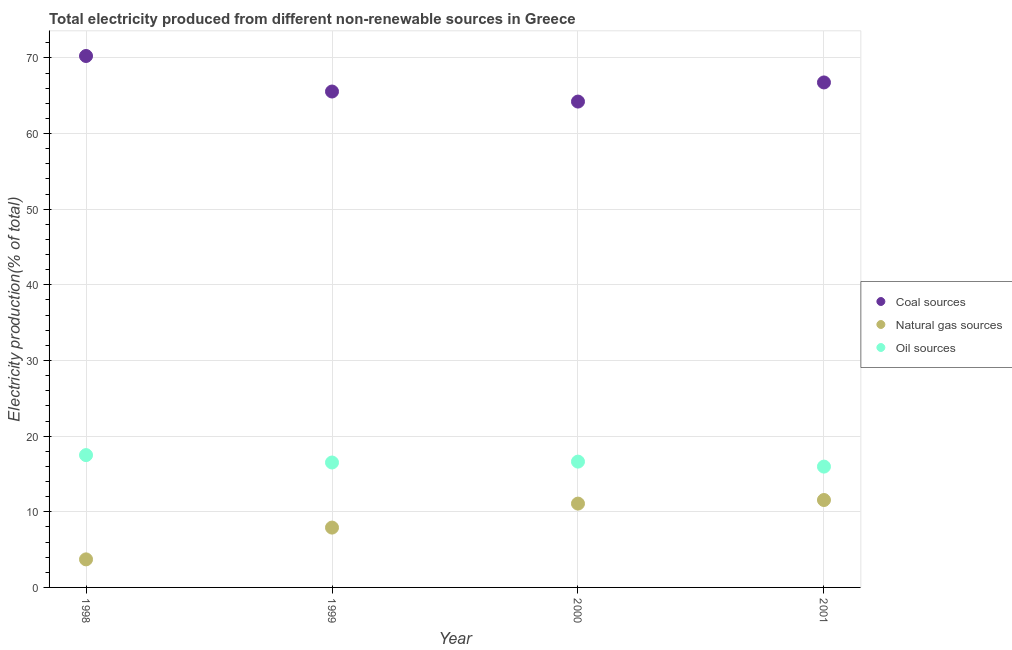How many different coloured dotlines are there?
Your answer should be very brief. 3. Is the number of dotlines equal to the number of legend labels?
Offer a terse response. Yes. What is the percentage of electricity produced by oil sources in 2001?
Your answer should be compact. 15.97. Across all years, what is the maximum percentage of electricity produced by coal?
Your answer should be compact. 70.25. Across all years, what is the minimum percentage of electricity produced by natural gas?
Provide a succinct answer. 3.71. In which year was the percentage of electricity produced by oil sources maximum?
Make the answer very short. 1998. In which year was the percentage of electricity produced by natural gas minimum?
Your response must be concise. 1998. What is the total percentage of electricity produced by natural gas in the graph?
Provide a succinct answer. 34.26. What is the difference between the percentage of electricity produced by oil sources in 1998 and that in 2000?
Provide a succinct answer. 0.86. What is the difference between the percentage of electricity produced by coal in 1999 and the percentage of electricity produced by oil sources in 2000?
Your answer should be very brief. 48.92. What is the average percentage of electricity produced by oil sources per year?
Your response must be concise. 16.65. In the year 2000, what is the difference between the percentage of electricity produced by natural gas and percentage of electricity produced by oil sources?
Provide a succinct answer. -5.55. In how many years, is the percentage of electricity produced by oil sources greater than 36 %?
Make the answer very short. 0. What is the ratio of the percentage of electricity produced by oil sources in 1999 to that in 2001?
Keep it short and to the point. 1.03. Is the percentage of electricity produced by coal in 1999 less than that in 2000?
Your answer should be very brief. No. What is the difference between the highest and the second highest percentage of electricity produced by oil sources?
Ensure brevity in your answer.  0.86. What is the difference between the highest and the lowest percentage of electricity produced by oil sources?
Your answer should be very brief. 1.52. In how many years, is the percentage of electricity produced by coal greater than the average percentage of electricity produced by coal taken over all years?
Provide a succinct answer. 2. Is it the case that in every year, the sum of the percentage of electricity produced by coal and percentage of electricity produced by natural gas is greater than the percentage of electricity produced by oil sources?
Give a very brief answer. Yes. Is the percentage of electricity produced by oil sources strictly greater than the percentage of electricity produced by coal over the years?
Your response must be concise. No. Is the percentage of electricity produced by coal strictly less than the percentage of electricity produced by natural gas over the years?
Offer a very short reply. No. What is the difference between two consecutive major ticks on the Y-axis?
Your answer should be very brief. 10. What is the title of the graph?
Your answer should be very brief. Total electricity produced from different non-renewable sources in Greece. What is the label or title of the Y-axis?
Give a very brief answer. Electricity production(% of total). What is the Electricity production(% of total) in Coal sources in 1998?
Your answer should be compact. 70.25. What is the Electricity production(% of total) of Natural gas sources in 1998?
Your answer should be very brief. 3.71. What is the Electricity production(% of total) in Oil sources in 1998?
Your answer should be very brief. 17.49. What is the Electricity production(% of total) in Coal sources in 1999?
Your response must be concise. 65.56. What is the Electricity production(% of total) of Natural gas sources in 1999?
Give a very brief answer. 7.91. What is the Electricity production(% of total) of Oil sources in 1999?
Offer a very short reply. 16.51. What is the Electricity production(% of total) in Coal sources in 2000?
Your answer should be very brief. 64.23. What is the Electricity production(% of total) in Natural gas sources in 2000?
Provide a succinct answer. 11.08. What is the Electricity production(% of total) in Oil sources in 2000?
Your answer should be very brief. 16.63. What is the Electricity production(% of total) of Coal sources in 2001?
Your answer should be compact. 66.76. What is the Electricity production(% of total) in Natural gas sources in 2001?
Ensure brevity in your answer.  11.56. What is the Electricity production(% of total) in Oil sources in 2001?
Make the answer very short. 15.97. Across all years, what is the maximum Electricity production(% of total) in Coal sources?
Your response must be concise. 70.25. Across all years, what is the maximum Electricity production(% of total) of Natural gas sources?
Offer a terse response. 11.56. Across all years, what is the maximum Electricity production(% of total) in Oil sources?
Give a very brief answer. 17.49. Across all years, what is the minimum Electricity production(% of total) in Coal sources?
Provide a succinct answer. 64.23. Across all years, what is the minimum Electricity production(% of total) of Natural gas sources?
Provide a short and direct response. 3.71. Across all years, what is the minimum Electricity production(% of total) in Oil sources?
Provide a short and direct response. 15.97. What is the total Electricity production(% of total) of Coal sources in the graph?
Your answer should be very brief. 266.79. What is the total Electricity production(% of total) of Natural gas sources in the graph?
Offer a very short reply. 34.26. What is the total Electricity production(% of total) in Oil sources in the graph?
Your answer should be compact. 66.61. What is the difference between the Electricity production(% of total) in Coal sources in 1998 and that in 1999?
Give a very brief answer. 4.7. What is the difference between the Electricity production(% of total) in Natural gas sources in 1998 and that in 1999?
Ensure brevity in your answer.  -4.2. What is the difference between the Electricity production(% of total) of Oil sources in 1998 and that in 1999?
Your answer should be compact. 0.98. What is the difference between the Electricity production(% of total) in Coal sources in 1998 and that in 2000?
Your answer should be very brief. 6.02. What is the difference between the Electricity production(% of total) in Natural gas sources in 1998 and that in 2000?
Your answer should be compact. -7.37. What is the difference between the Electricity production(% of total) of Oil sources in 1998 and that in 2000?
Provide a succinct answer. 0.86. What is the difference between the Electricity production(% of total) of Coal sources in 1998 and that in 2001?
Your answer should be very brief. 3.5. What is the difference between the Electricity production(% of total) in Natural gas sources in 1998 and that in 2001?
Provide a short and direct response. -7.85. What is the difference between the Electricity production(% of total) in Oil sources in 1998 and that in 2001?
Offer a terse response. 1.52. What is the difference between the Electricity production(% of total) in Coal sources in 1999 and that in 2000?
Your answer should be compact. 1.33. What is the difference between the Electricity production(% of total) of Natural gas sources in 1999 and that in 2000?
Offer a terse response. -3.17. What is the difference between the Electricity production(% of total) in Oil sources in 1999 and that in 2000?
Your answer should be compact. -0.12. What is the difference between the Electricity production(% of total) of Natural gas sources in 1999 and that in 2001?
Make the answer very short. -3.65. What is the difference between the Electricity production(% of total) in Oil sources in 1999 and that in 2001?
Your answer should be compact. 0.54. What is the difference between the Electricity production(% of total) in Coal sources in 2000 and that in 2001?
Give a very brief answer. -2.53. What is the difference between the Electricity production(% of total) in Natural gas sources in 2000 and that in 2001?
Offer a very short reply. -0.47. What is the difference between the Electricity production(% of total) in Oil sources in 2000 and that in 2001?
Provide a short and direct response. 0.66. What is the difference between the Electricity production(% of total) in Coal sources in 1998 and the Electricity production(% of total) in Natural gas sources in 1999?
Your answer should be compact. 62.34. What is the difference between the Electricity production(% of total) of Coal sources in 1998 and the Electricity production(% of total) of Oil sources in 1999?
Make the answer very short. 53.74. What is the difference between the Electricity production(% of total) in Natural gas sources in 1998 and the Electricity production(% of total) in Oil sources in 1999?
Keep it short and to the point. -12.8. What is the difference between the Electricity production(% of total) of Coal sources in 1998 and the Electricity production(% of total) of Natural gas sources in 2000?
Your response must be concise. 59.17. What is the difference between the Electricity production(% of total) in Coal sources in 1998 and the Electricity production(% of total) in Oil sources in 2000?
Offer a very short reply. 53.62. What is the difference between the Electricity production(% of total) of Natural gas sources in 1998 and the Electricity production(% of total) of Oil sources in 2000?
Keep it short and to the point. -12.92. What is the difference between the Electricity production(% of total) of Coal sources in 1998 and the Electricity production(% of total) of Natural gas sources in 2001?
Provide a short and direct response. 58.7. What is the difference between the Electricity production(% of total) in Coal sources in 1998 and the Electricity production(% of total) in Oil sources in 2001?
Provide a succinct answer. 54.28. What is the difference between the Electricity production(% of total) in Natural gas sources in 1998 and the Electricity production(% of total) in Oil sources in 2001?
Make the answer very short. -12.26. What is the difference between the Electricity production(% of total) of Coal sources in 1999 and the Electricity production(% of total) of Natural gas sources in 2000?
Keep it short and to the point. 54.47. What is the difference between the Electricity production(% of total) in Coal sources in 1999 and the Electricity production(% of total) in Oil sources in 2000?
Give a very brief answer. 48.92. What is the difference between the Electricity production(% of total) of Natural gas sources in 1999 and the Electricity production(% of total) of Oil sources in 2000?
Ensure brevity in your answer.  -8.72. What is the difference between the Electricity production(% of total) of Coal sources in 1999 and the Electricity production(% of total) of Natural gas sources in 2001?
Offer a terse response. 54. What is the difference between the Electricity production(% of total) of Coal sources in 1999 and the Electricity production(% of total) of Oil sources in 2001?
Your answer should be very brief. 49.58. What is the difference between the Electricity production(% of total) in Natural gas sources in 1999 and the Electricity production(% of total) in Oil sources in 2001?
Provide a succinct answer. -8.06. What is the difference between the Electricity production(% of total) in Coal sources in 2000 and the Electricity production(% of total) in Natural gas sources in 2001?
Your response must be concise. 52.67. What is the difference between the Electricity production(% of total) of Coal sources in 2000 and the Electricity production(% of total) of Oil sources in 2001?
Provide a short and direct response. 48.26. What is the difference between the Electricity production(% of total) of Natural gas sources in 2000 and the Electricity production(% of total) of Oil sources in 2001?
Ensure brevity in your answer.  -4.89. What is the average Electricity production(% of total) in Coal sources per year?
Ensure brevity in your answer.  66.7. What is the average Electricity production(% of total) in Natural gas sources per year?
Provide a succinct answer. 8.56. What is the average Electricity production(% of total) in Oil sources per year?
Provide a succinct answer. 16.65. In the year 1998, what is the difference between the Electricity production(% of total) of Coal sources and Electricity production(% of total) of Natural gas sources?
Your response must be concise. 66.54. In the year 1998, what is the difference between the Electricity production(% of total) in Coal sources and Electricity production(% of total) in Oil sources?
Your answer should be compact. 52.76. In the year 1998, what is the difference between the Electricity production(% of total) in Natural gas sources and Electricity production(% of total) in Oil sources?
Offer a very short reply. -13.78. In the year 1999, what is the difference between the Electricity production(% of total) of Coal sources and Electricity production(% of total) of Natural gas sources?
Provide a short and direct response. 57.65. In the year 1999, what is the difference between the Electricity production(% of total) in Coal sources and Electricity production(% of total) in Oil sources?
Offer a very short reply. 49.04. In the year 1999, what is the difference between the Electricity production(% of total) in Natural gas sources and Electricity production(% of total) in Oil sources?
Your answer should be compact. -8.6. In the year 2000, what is the difference between the Electricity production(% of total) of Coal sources and Electricity production(% of total) of Natural gas sources?
Your response must be concise. 53.15. In the year 2000, what is the difference between the Electricity production(% of total) of Coal sources and Electricity production(% of total) of Oil sources?
Ensure brevity in your answer.  47.6. In the year 2000, what is the difference between the Electricity production(% of total) of Natural gas sources and Electricity production(% of total) of Oil sources?
Ensure brevity in your answer.  -5.55. In the year 2001, what is the difference between the Electricity production(% of total) of Coal sources and Electricity production(% of total) of Natural gas sources?
Keep it short and to the point. 55.2. In the year 2001, what is the difference between the Electricity production(% of total) in Coal sources and Electricity production(% of total) in Oil sources?
Your response must be concise. 50.78. In the year 2001, what is the difference between the Electricity production(% of total) of Natural gas sources and Electricity production(% of total) of Oil sources?
Give a very brief answer. -4.42. What is the ratio of the Electricity production(% of total) of Coal sources in 1998 to that in 1999?
Ensure brevity in your answer.  1.07. What is the ratio of the Electricity production(% of total) of Natural gas sources in 1998 to that in 1999?
Your answer should be compact. 0.47. What is the ratio of the Electricity production(% of total) of Oil sources in 1998 to that in 1999?
Provide a succinct answer. 1.06. What is the ratio of the Electricity production(% of total) of Coal sources in 1998 to that in 2000?
Ensure brevity in your answer.  1.09. What is the ratio of the Electricity production(% of total) in Natural gas sources in 1998 to that in 2000?
Offer a very short reply. 0.33. What is the ratio of the Electricity production(% of total) of Oil sources in 1998 to that in 2000?
Offer a very short reply. 1.05. What is the ratio of the Electricity production(% of total) in Coal sources in 1998 to that in 2001?
Make the answer very short. 1.05. What is the ratio of the Electricity production(% of total) of Natural gas sources in 1998 to that in 2001?
Your answer should be compact. 0.32. What is the ratio of the Electricity production(% of total) in Oil sources in 1998 to that in 2001?
Make the answer very short. 1.1. What is the ratio of the Electricity production(% of total) of Coal sources in 1999 to that in 2000?
Offer a terse response. 1.02. What is the ratio of the Electricity production(% of total) of Natural gas sources in 1999 to that in 2000?
Offer a very short reply. 0.71. What is the ratio of the Electricity production(% of total) in Oil sources in 1999 to that in 2000?
Ensure brevity in your answer.  0.99. What is the ratio of the Electricity production(% of total) of Coal sources in 1999 to that in 2001?
Your answer should be compact. 0.98. What is the ratio of the Electricity production(% of total) in Natural gas sources in 1999 to that in 2001?
Keep it short and to the point. 0.68. What is the ratio of the Electricity production(% of total) in Oil sources in 1999 to that in 2001?
Your response must be concise. 1.03. What is the ratio of the Electricity production(% of total) in Coal sources in 2000 to that in 2001?
Provide a short and direct response. 0.96. What is the ratio of the Electricity production(% of total) of Oil sources in 2000 to that in 2001?
Ensure brevity in your answer.  1.04. What is the difference between the highest and the second highest Electricity production(% of total) in Coal sources?
Keep it short and to the point. 3.5. What is the difference between the highest and the second highest Electricity production(% of total) in Natural gas sources?
Make the answer very short. 0.47. What is the difference between the highest and the second highest Electricity production(% of total) in Oil sources?
Keep it short and to the point. 0.86. What is the difference between the highest and the lowest Electricity production(% of total) of Coal sources?
Your answer should be very brief. 6.02. What is the difference between the highest and the lowest Electricity production(% of total) in Natural gas sources?
Offer a terse response. 7.85. What is the difference between the highest and the lowest Electricity production(% of total) of Oil sources?
Give a very brief answer. 1.52. 